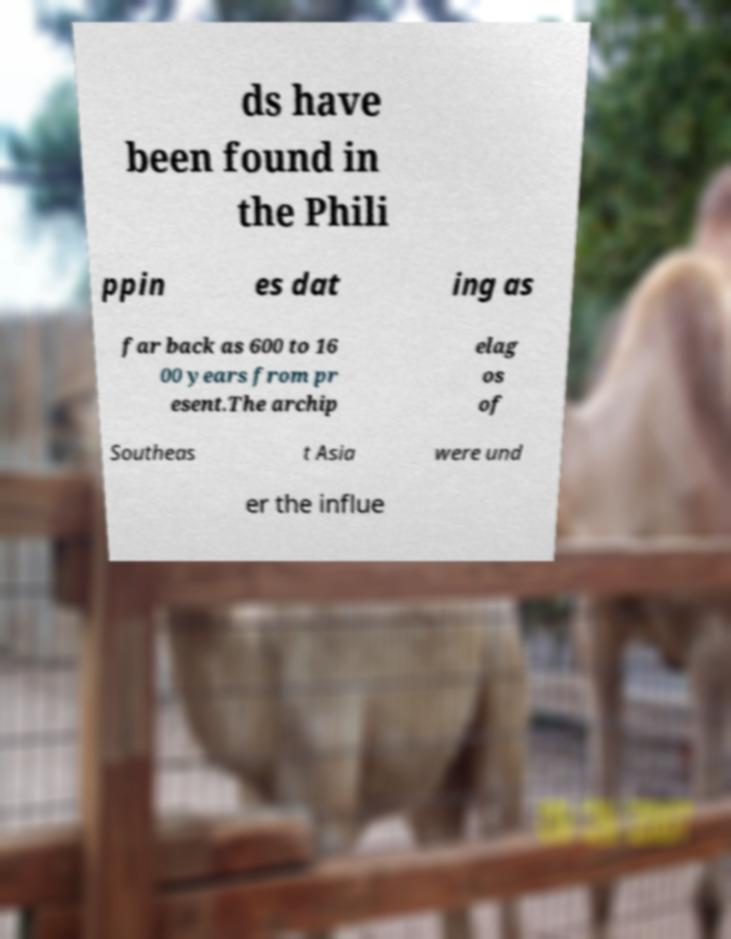Can you read and provide the text displayed in the image?This photo seems to have some interesting text. Can you extract and type it out for me? ds have been found in the Phili ppin es dat ing as far back as 600 to 16 00 years from pr esent.The archip elag os of Southeas t Asia were und er the influe 